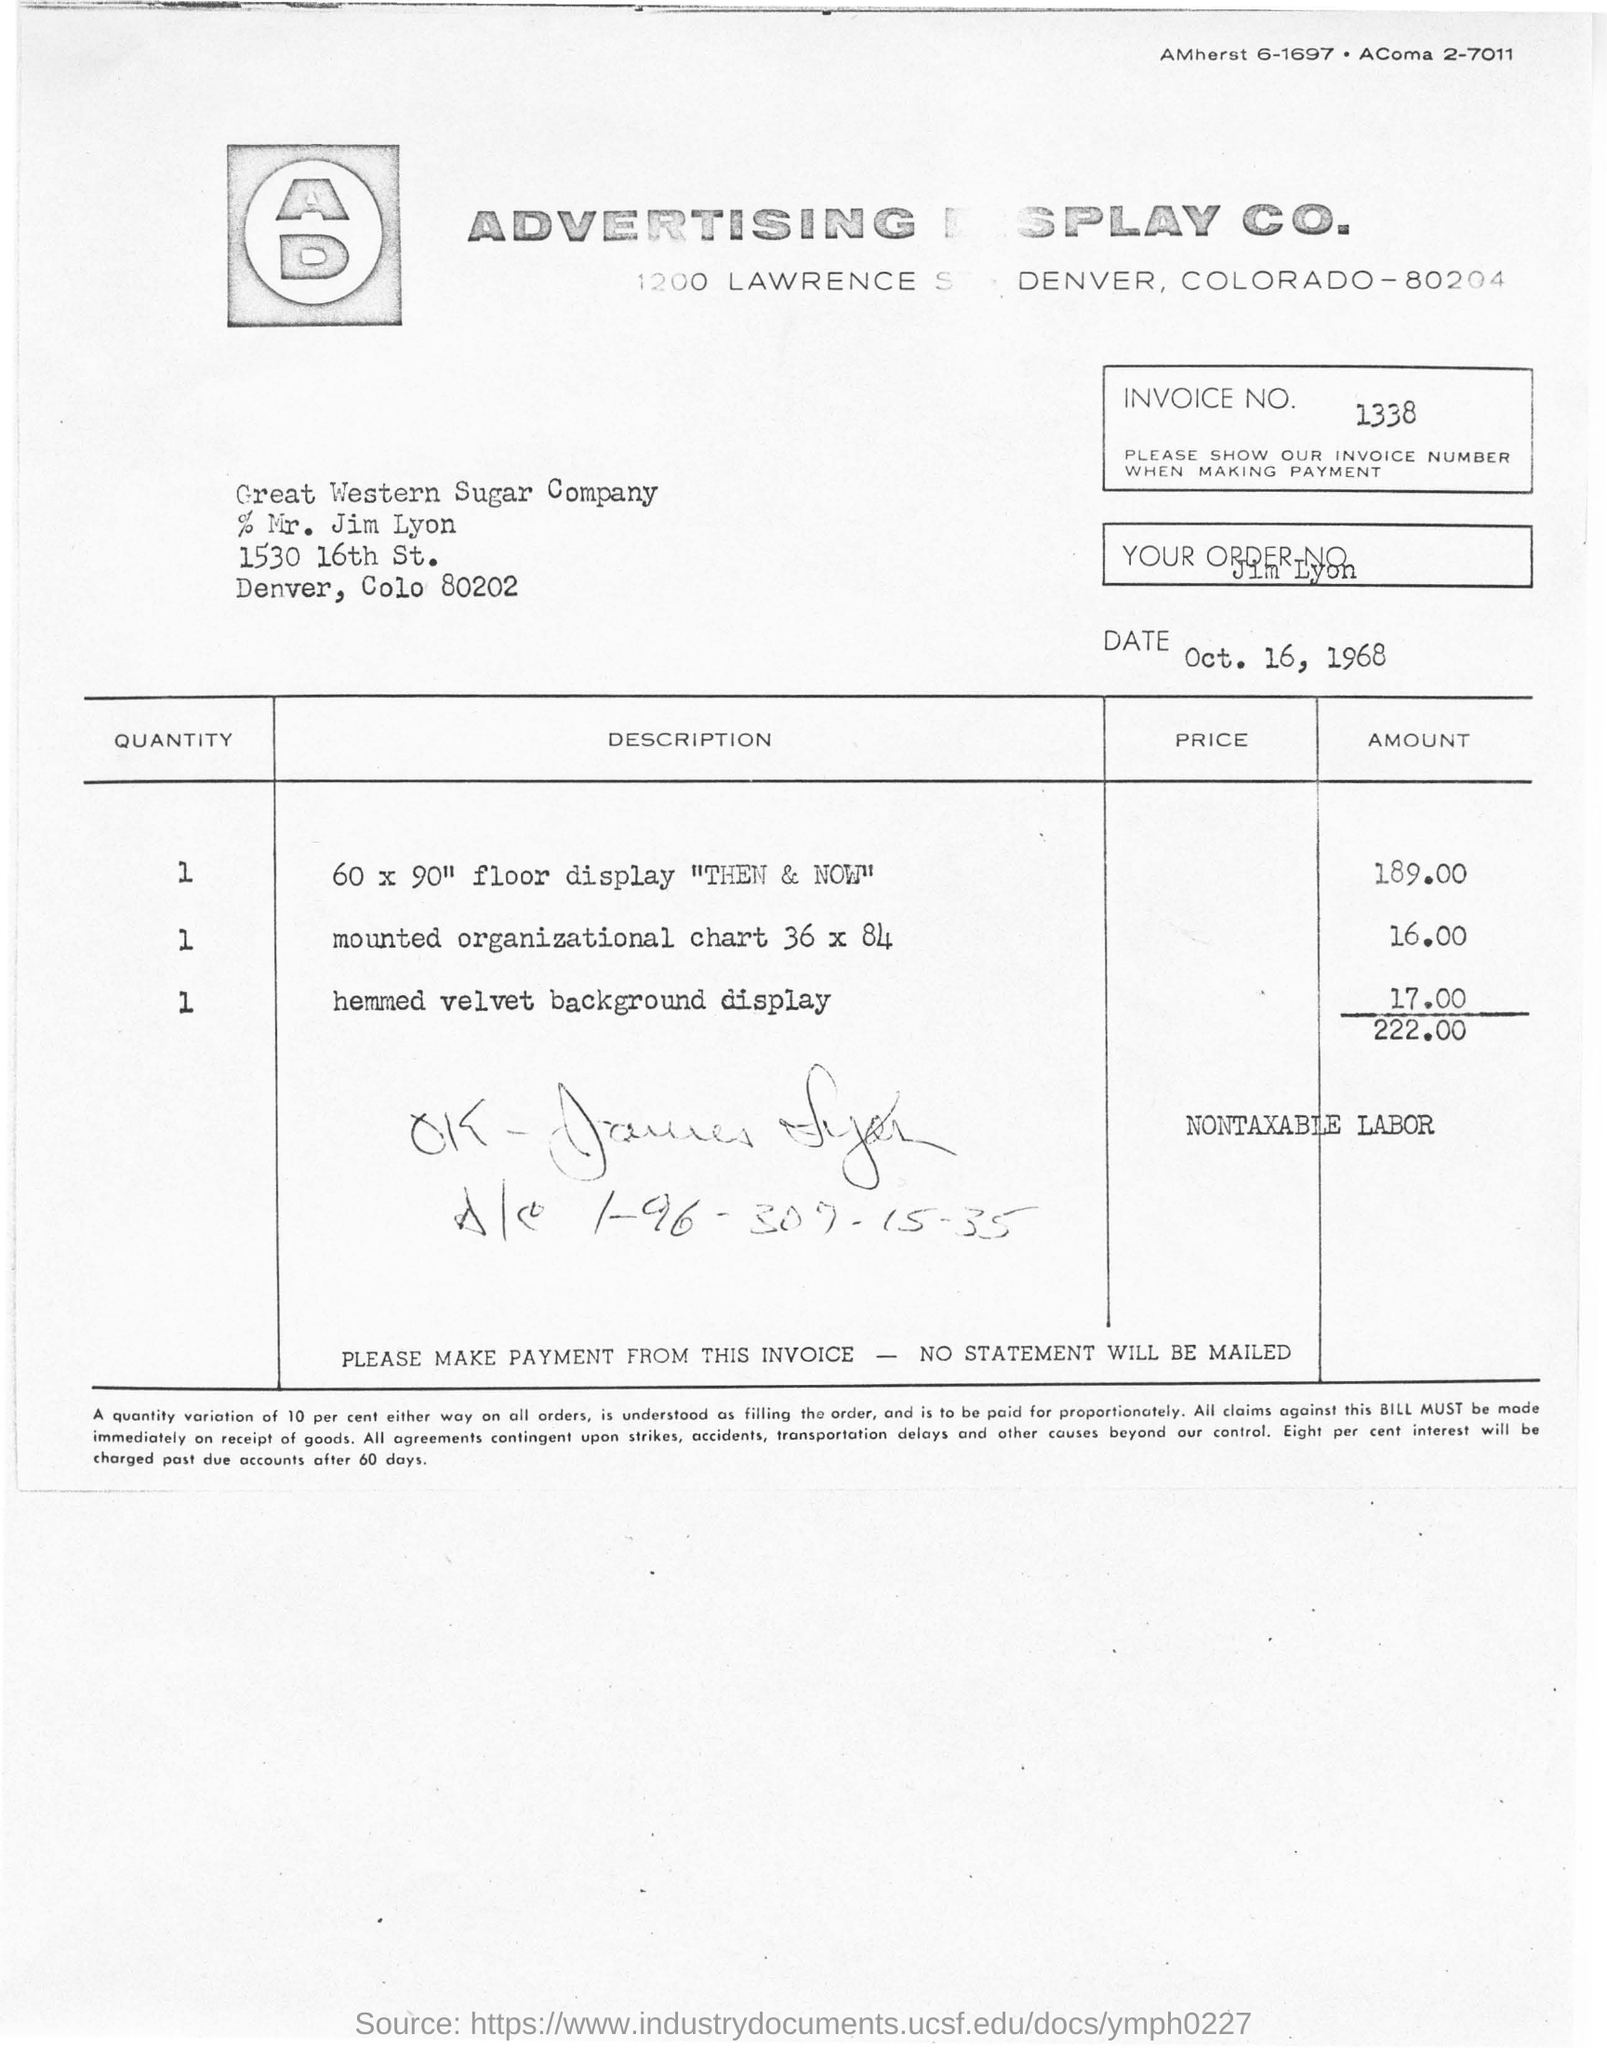What is the invoice number for this invoice?
Keep it short and to the point. 1338. What date was the invoice issued on?
Your answer should be compact. OCT. 16, 1968. What is the total amount in the invoice?
Provide a succinct answer. 222 00. 